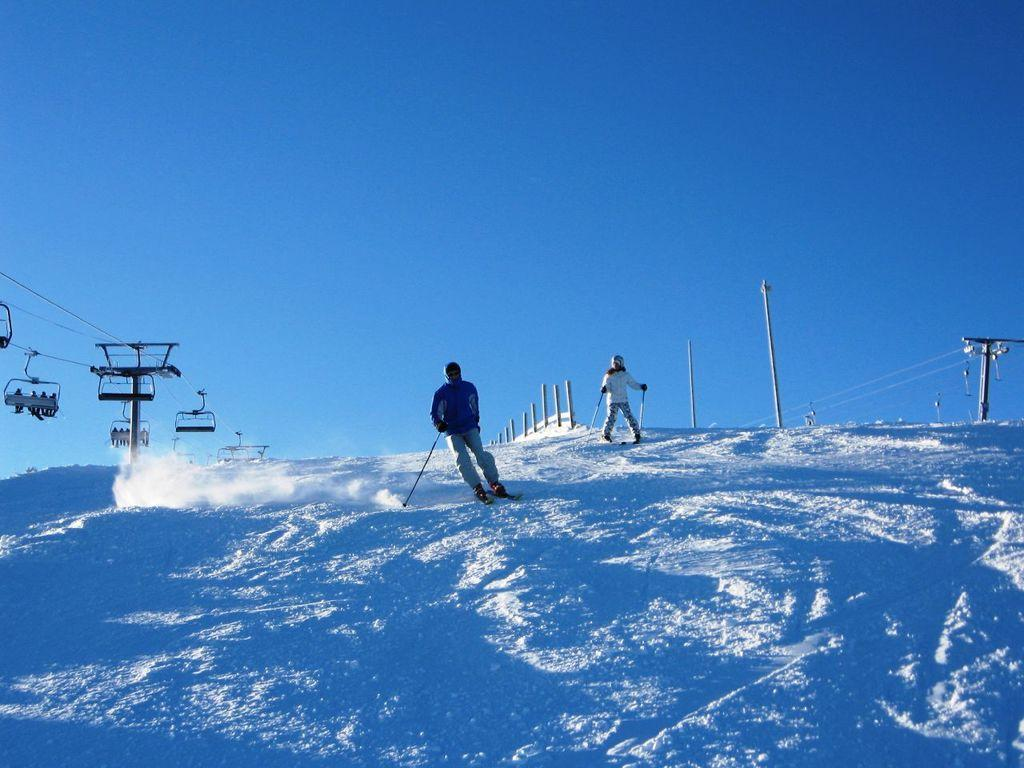What is the primary feature of the landscape in the image? There is snow in the image. How many people are in the image? There are two people in the image. What are the people doing in the image? The people are riding on the snow floor. What objects are the people holding in their hands? The people are holding rods in their hands. What can be seen along the path of the snow floor? There are poles on the way of the snow floor. What type of net can be seen in the image? There is no net present in the image. What kind of shoe is the person wearing on their right foot? There is no shoe visible in the image, as the people are riding on the snow floor and their feet are not visible. 